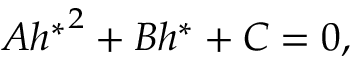<formula> <loc_0><loc_0><loc_500><loc_500>A { h ^ { \ast } } ^ { 2 } + B h ^ { \ast } + C = 0 ,</formula> 